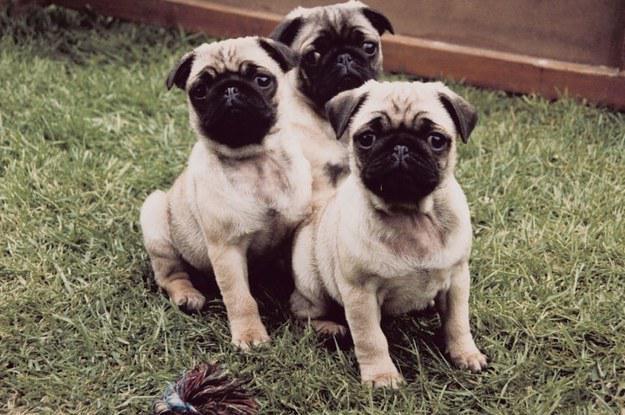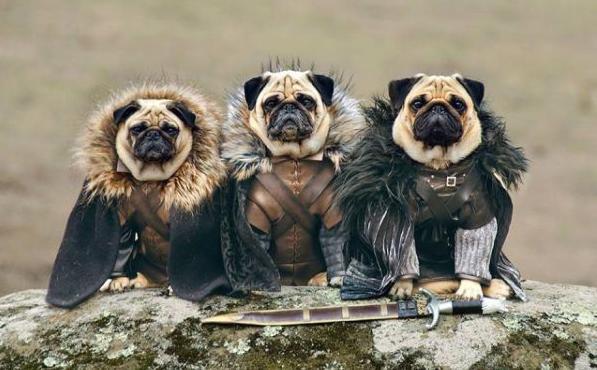The first image is the image on the left, the second image is the image on the right. For the images shown, is this caption "At least one image includes black pugs." true? Answer yes or no. No. The first image is the image on the left, the second image is the image on the right. Assess this claim about the two images: "There are no more than four puppies in the image on the right.". Correct or not? Answer yes or no. Yes. 